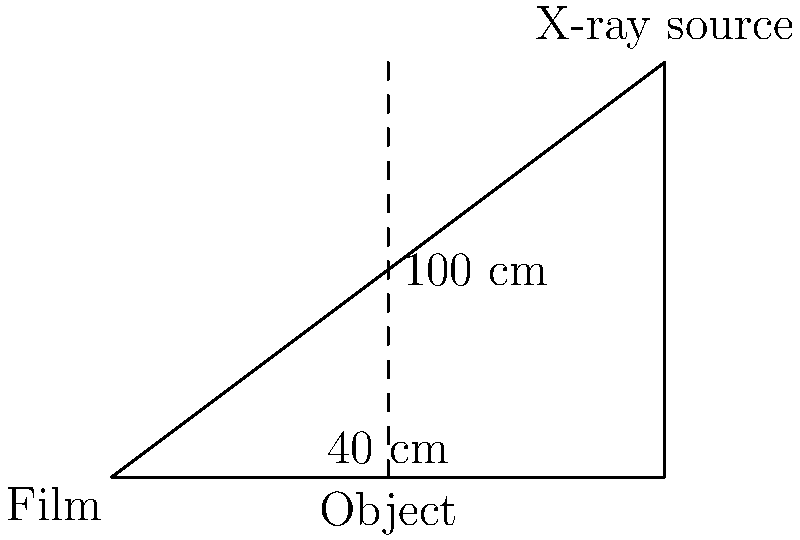In the diagram above, an X-ray image is being taken of an object. The distance from the X-ray source to the film is 100 cm, and the object is placed 40 cm above the film. Calculate the percentage of image magnification on the film. To calculate the percentage of image magnification, we need to follow these steps:

1. Understand the concept: Image magnification occurs when the object is closer to the X-ray source than to the film.

2. Use the magnification formula:
   $$ \text{Magnification} = \frac{\text{Source-to-Film Distance (SFD)}}{\text{Source-to-Object Distance (SOD)}} $$

3. Calculate the Source-to-Object Distance (SOD):
   $$ \text{SOD} = \text{SFD} - \text{Object-to-Film Distance} $$
   $$ \text{SOD} = 100 \text{ cm} - 40 \text{ cm} = 60 \text{ cm} $$

4. Apply the magnification formula:
   $$ \text{Magnification} = \frac{100 \text{ cm}}{60 \text{ cm}} = 1.67 $$

5. Convert the magnification factor to a percentage:
   $$ \text{Percentage Magnification} = (\text{Magnification} - 1) \times 100\% $$
   $$ \text{Percentage Magnification} = (1.67 - 1) \times 100\% = 67\% $$

Thus, the image magnification on the film is 67%.
Answer: 67% 